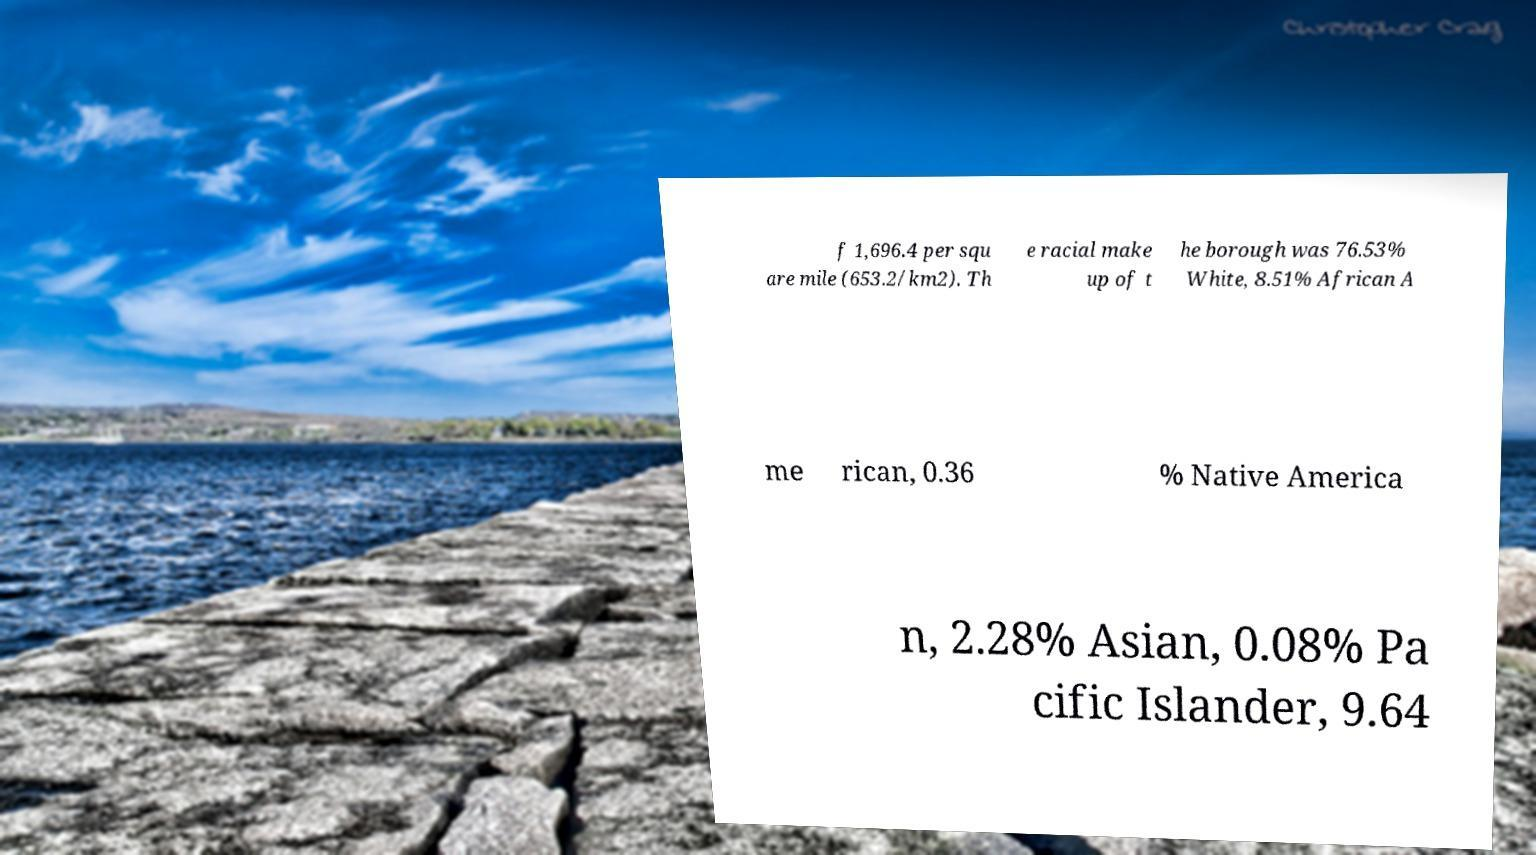There's text embedded in this image that I need extracted. Can you transcribe it verbatim? f 1,696.4 per squ are mile (653.2/km2). Th e racial make up of t he borough was 76.53% White, 8.51% African A me rican, 0.36 % Native America n, 2.28% Asian, 0.08% Pa cific Islander, 9.64 